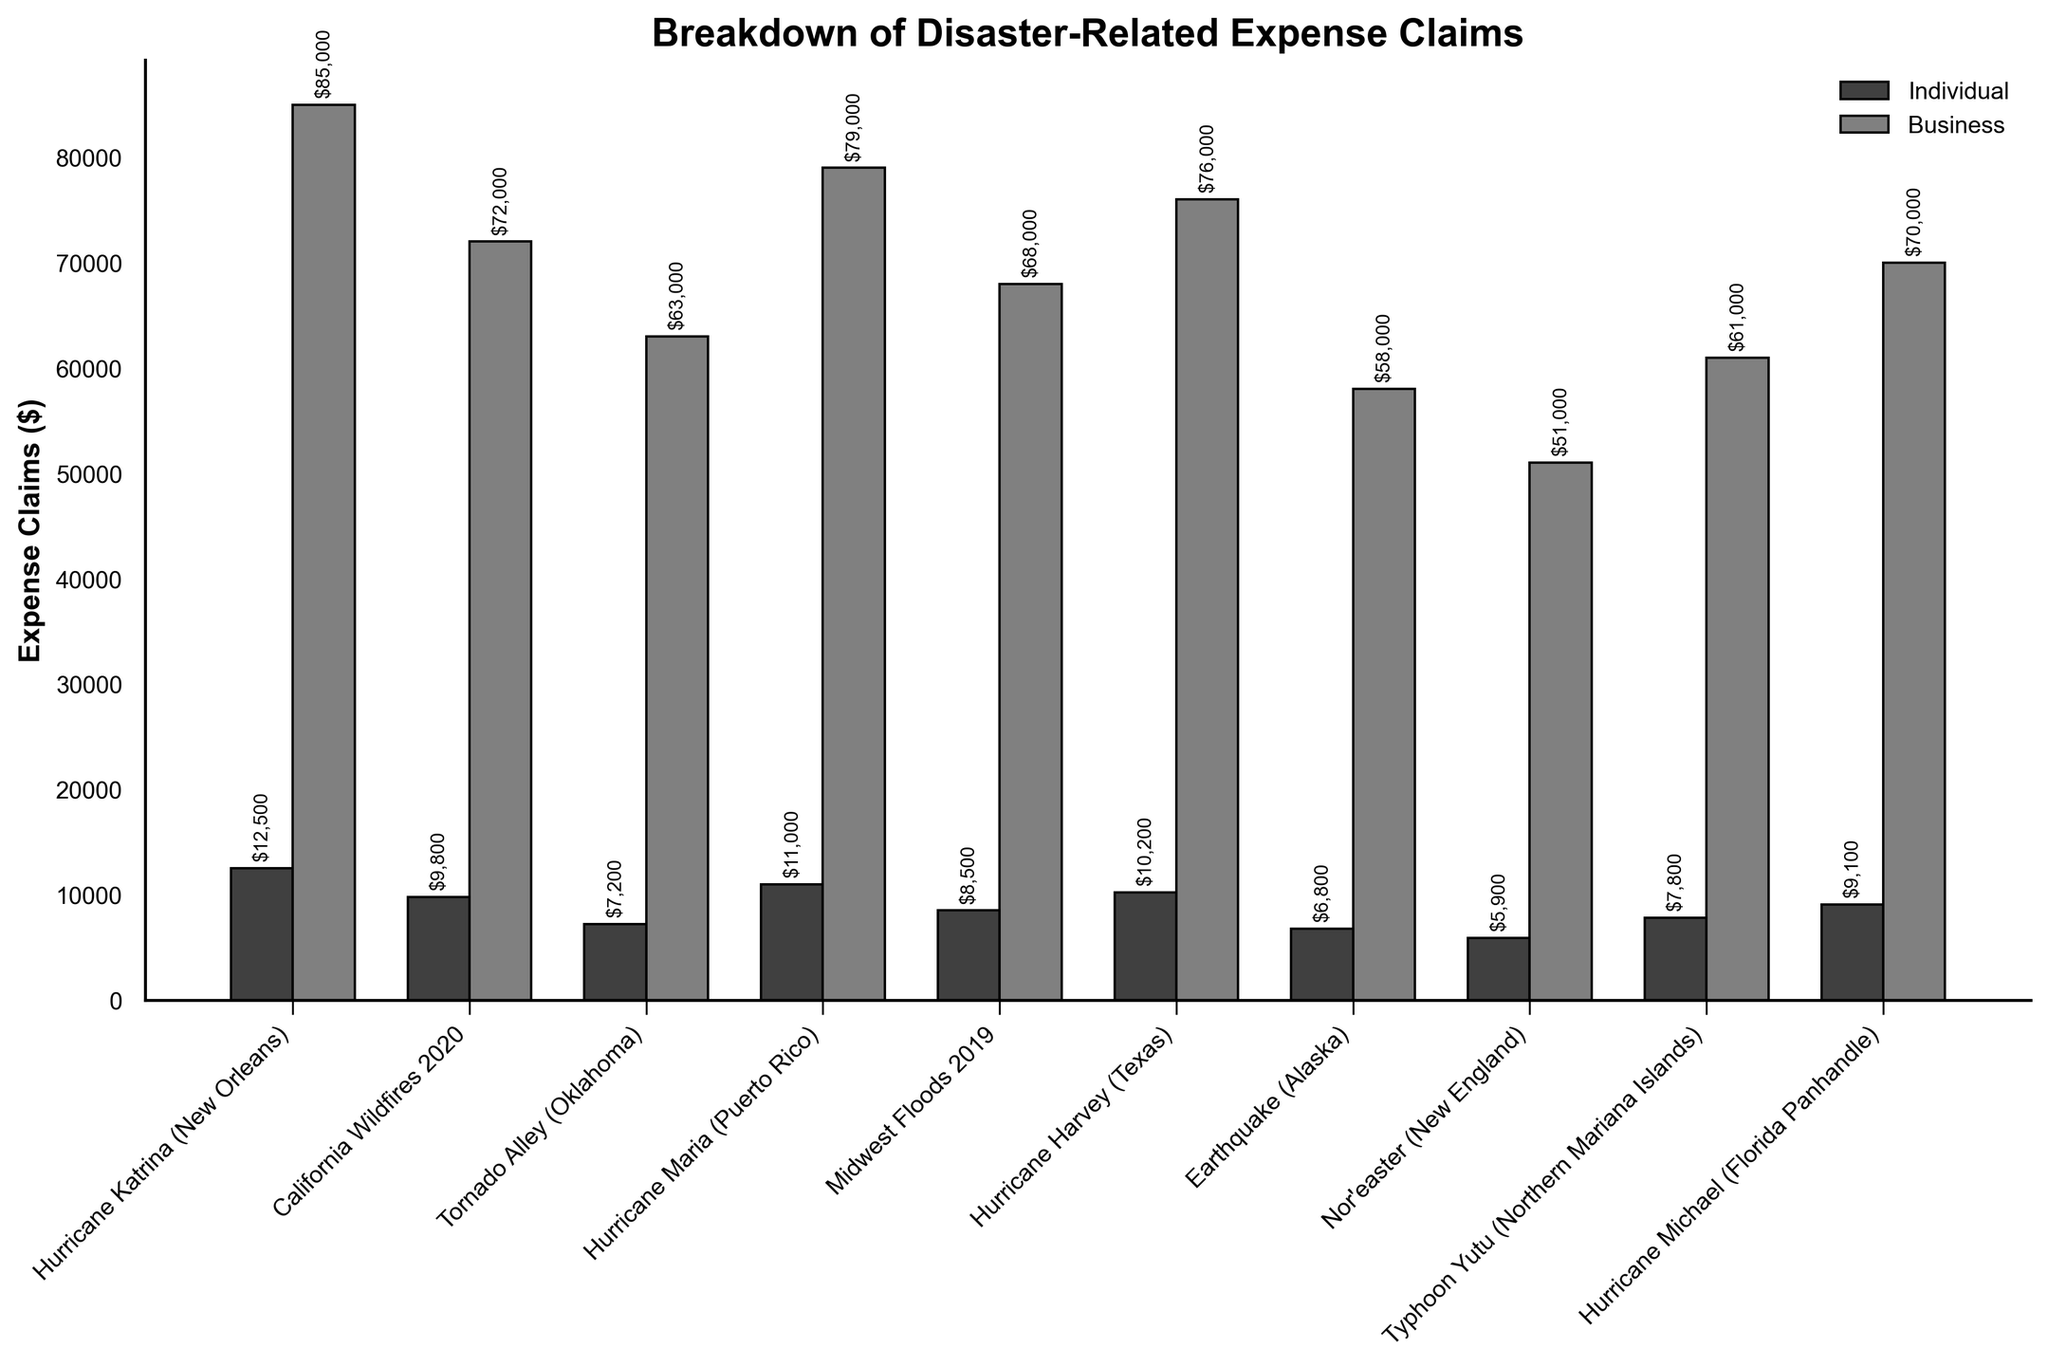Which disaster zones have higher business expense claims than individual expense claims? By visually scanning the chart, identify the bars representing business expense claims that are taller than the bars for individual expense claims in the same zone.
Answer: All zones What is the total combined expense claim (individual and business) for Hurricane Katrina (New Orleans)? Sum the height values of the bars for Hurricane Katrina (New Orleans) in the individual and business categories. $12,500 + $85,000 = $97,500
Answer: $97,500 Which disaster zone has the highest individual expense claims? Look at the height of the individual expense claim bars and find the tallest one. Hurricane Katrina (New Orleans) has the highest individual expense claim bar.
Answer: Hurricane Katrina (New Orleans) How do the individual expense claims for Hurricane Maria (Puerto Rico) compare to those for Hurricane Harvey (Texas)? Compare the heights of the individual expense claim bars for Hurricane Maria (Puerto Rico) and Hurricane Harvey (Texas). $11,000 (Hurricane Maria) is greater than $10,200 (Hurricane Harvey).
Answer: Hurricane Maria (Puerto Rico) has higher individual expense claims than Hurricane Harvey (Texas) Which disaster zone has the smallest difference between individual and business expense claims? Calculate the difference between individual and business expense claims for each zone and find the smallest one: (Hurricane Katrina: $72,500, California Wildfires: $62,200, Tornado Alley: $55,800, Hurricane Maria: $68,000, Midwest Floods: $59,500, Hurricane Harvey: $65,800, Earthquake Alaska: $51,200, Nor’easter: $45,100, Typhoon Yutu: $53,200, Hurricane Michael: $60,900). The smallest difference is for Nor’easter (New England) $45,100.
Answer: Nor’easter (New England) Rank the disaster zones by the total expense claims from highest to lowest. For each disaster zone, sum the individual and business expense claims and then order them: (Hurricane Katrina $97,500, Hurricane Maria $90,000, Hurricane Harvey $86,200, California Wildfires $81,800, Hurricane Michael $79,100, Midwest Floods $76,500, Typhoon Yutu $68,800, Tornado Alley $70,200, Earthquake Alaska $64,800, Nor’easter $56,900). The ranking is: Hurricane Katrina, Hurricane Maria, Hurricane Harvey, California Wildfires, Hurricane Michael, Midwest Floods, Tornado Alley, Typhoon Yutu, Earthquake Alaska, Nor’easter.
Answer: Hurricane Katrina, Hurricane Maria, Hurricane Harvey, California Wildfires, Hurricane Michael, Midwest Floods, Tornado Alley, Typhoon Yutu, Earthquake (Alaska), Nor’easter (New England) What is the average business expense claim across all disaster zones? Sum all the business expense claims and divide by the number of zones: (85,000 + 72,000 + 63,000 + 79,000 + 68,000 + 76,000 + 58,000 + 51,000 + 61,000 + 70,000) / 10 = 683,000 / 10 = 68,300
Answer: $68,300 How much higher is the business expense claim compared to the individual claim in the California Wildfires zone? Subtract the individual claims from the business claims for California Wildfires: $72,000 - $9,800 = $62,200
Answer: $62,200 